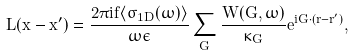<formula> <loc_0><loc_0><loc_500><loc_500>L ( x - x ^ { \prime } ) = \frac { 2 \pi i f \langle \sigma _ { 1 D } ( \omega ) \rangle } { \omega \epsilon } \sum _ { G } \frac { W ( { G } , \omega ) } { \kappa _ { G } } e ^ { i { G \cdot ( r - r ^ { \prime } ) } } ,</formula> 